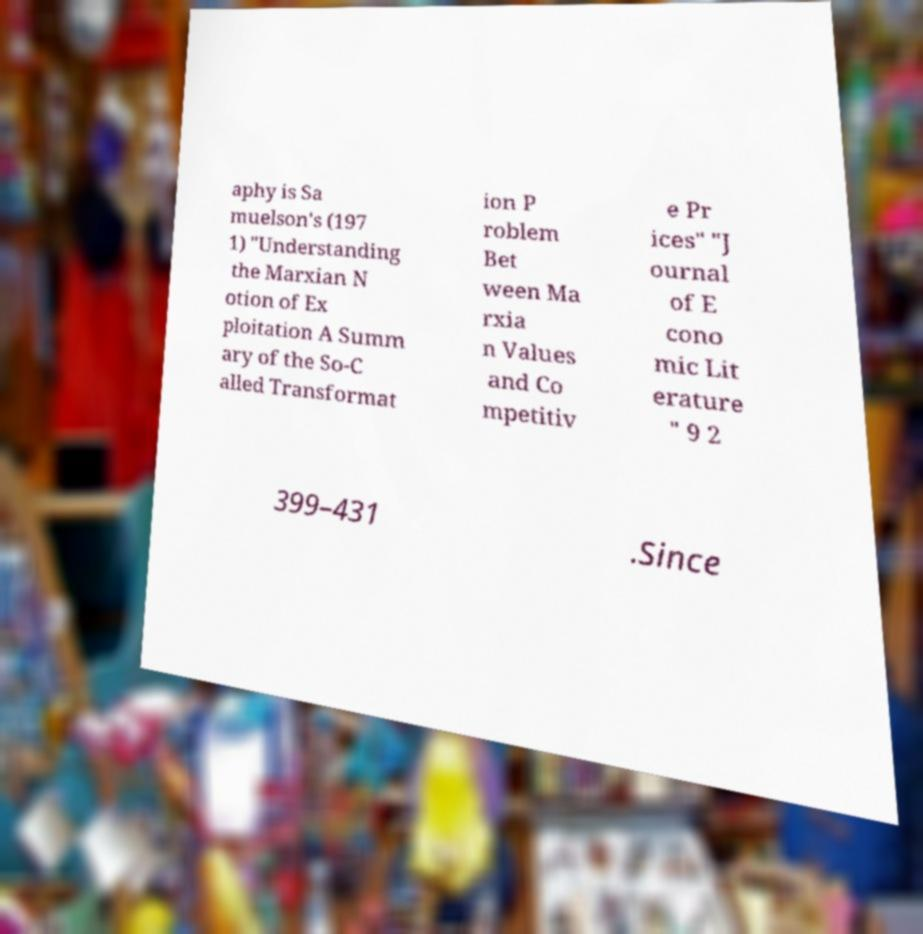Please read and relay the text visible in this image. What does it say? aphy is Sa muelson's (197 1) "Understanding the Marxian N otion of Ex ploitation A Summ ary of the So-C alled Transformat ion P roblem Bet ween Ma rxia n Values and Co mpetitiv e Pr ices" "J ournal of E cono mic Lit erature " 9 2 399–431 .Since 